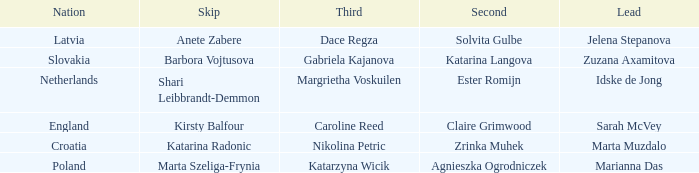What is the name of the third who has Barbora Vojtusova as Skip? Gabriela Kajanova. 